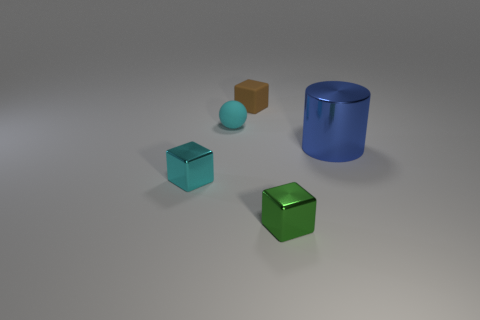How many things are tiny gray matte balls or brown rubber things?
Your answer should be compact. 1. How many matte cubes are to the right of the blue shiny object that is on the right side of the cyan object that is behind the blue shiny cylinder?
Keep it short and to the point. 0. Is there any other thing of the same color as the small ball?
Give a very brief answer. Yes. Do the metallic cube on the left side of the matte ball and the matte thing in front of the brown matte thing have the same color?
Your answer should be compact. Yes. Are there more shiny cylinders to the right of the green thing than large blue cylinders that are on the left side of the small cyan matte ball?
Provide a short and direct response. Yes. What material is the tiny cyan sphere?
Offer a terse response. Rubber. There is a cyan object behind the metal thing that is right of the tiny metal object that is right of the cyan shiny block; what shape is it?
Provide a succinct answer. Sphere. How many other objects are there of the same material as the small green block?
Your response must be concise. 2. Do the tiny block on the right side of the small brown cube and the cyan object that is in front of the blue cylinder have the same material?
Offer a very short reply. Yes. How many blocks are both behind the cyan metal thing and right of the small brown cube?
Offer a terse response. 0. 